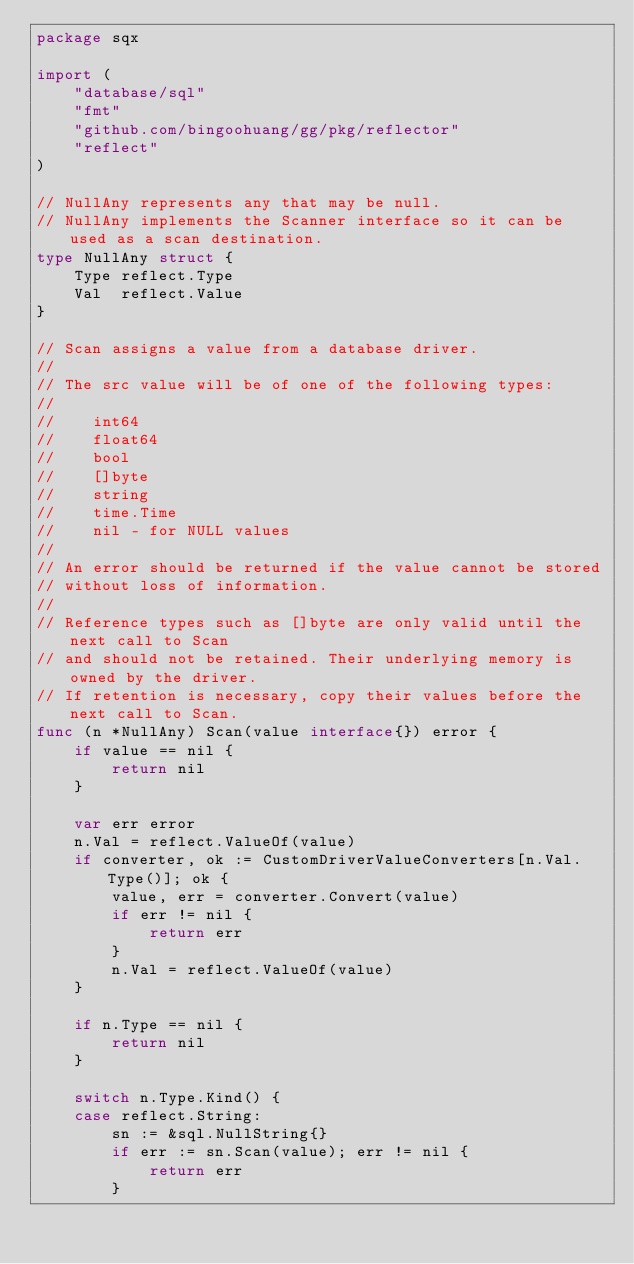Convert code to text. <code><loc_0><loc_0><loc_500><loc_500><_Go_>package sqx

import (
	"database/sql"
	"fmt"
	"github.com/bingoohuang/gg/pkg/reflector"
	"reflect"
)

// NullAny represents any that may be null.
// NullAny implements the Scanner interface so it can be used as a scan destination.
type NullAny struct {
	Type reflect.Type
	Val  reflect.Value
}

// Scan assigns a value from a database driver.
//
// The src value will be of one of the following types:
//
//    int64
//    float64
//    bool
//    []byte
//    string
//    time.Time
//    nil - for NULL values
//
// An error should be returned if the value cannot be stored
// without loss of information.
//
// Reference types such as []byte are only valid until the next call to Scan
// and should not be retained. Their underlying memory is owned by the driver.
// If retention is necessary, copy their values before the next call to Scan.
func (n *NullAny) Scan(value interface{}) error {
	if value == nil {
		return nil
	}

	var err error
	n.Val = reflect.ValueOf(value)
	if converter, ok := CustomDriverValueConverters[n.Val.Type()]; ok {
		value, err = converter.Convert(value)
		if err != nil {
			return err
		}
		n.Val = reflect.ValueOf(value)
	}

	if n.Type == nil {
		return nil
	}

	switch n.Type.Kind() {
	case reflect.String:
		sn := &sql.NullString{}
		if err := sn.Scan(value); err != nil {
			return err
		}
</code> 